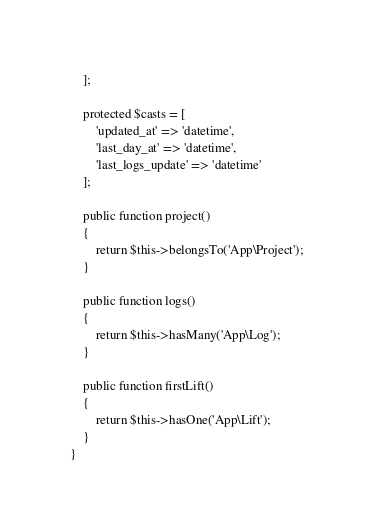<code> <loc_0><loc_0><loc_500><loc_500><_PHP_>    ];

    protected $casts = [
        'updated_at' => 'datetime',
        'last_day_at' => 'datetime',
        'last_logs_update' => 'datetime'
    ];

    public function project()
    {
        return $this->belongsTo('App\Project');
    }

    public function logs()
    {
        return $this->hasMany('App\Log');
    }

    public function firstLift()
    {
        return $this->hasOne('App\Lift');
    }
}</code> 